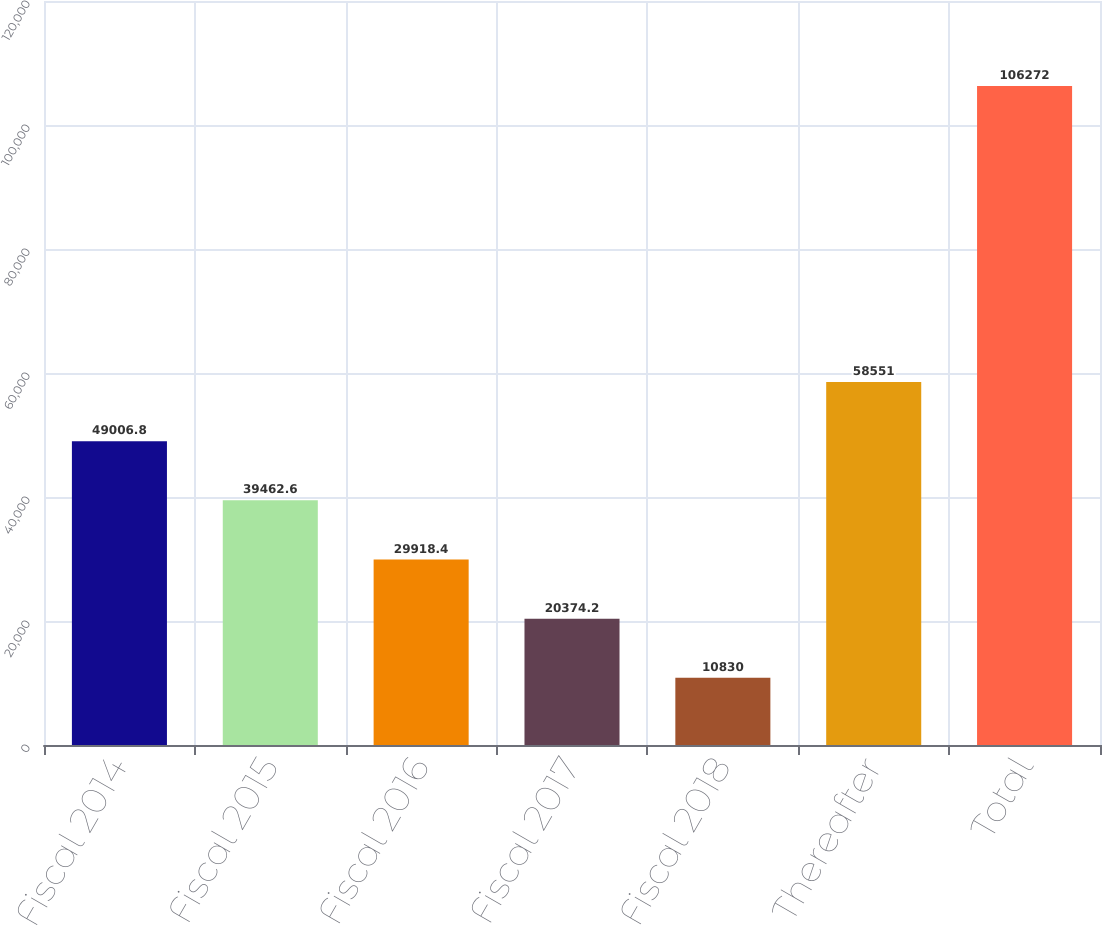Convert chart to OTSL. <chart><loc_0><loc_0><loc_500><loc_500><bar_chart><fcel>Fiscal 2014<fcel>Fiscal 2015<fcel>Fiscal 2016<fcel>Fiscal 2017<fcel>Fiscal 2018<fcel>Thereafter<fcel>Total<nl><fcel>49006.8<fcel>39462.6<fcel>29918.4<fcel>20374.2<fcel>10830<fcel>58551<fcel>106272<nl></chart> 